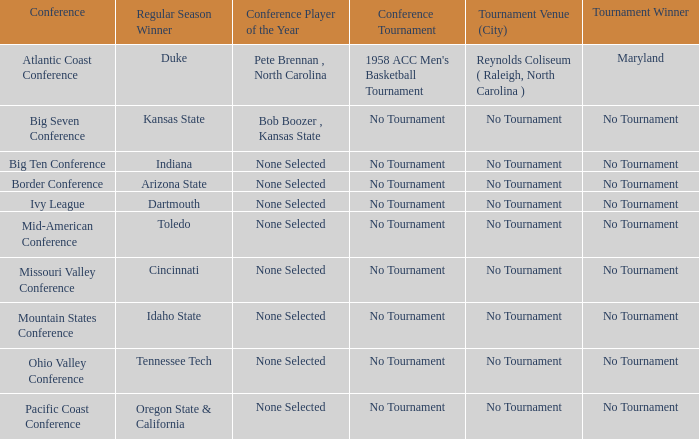What was the conference when Arizona State won the regular season? Border Conference. 